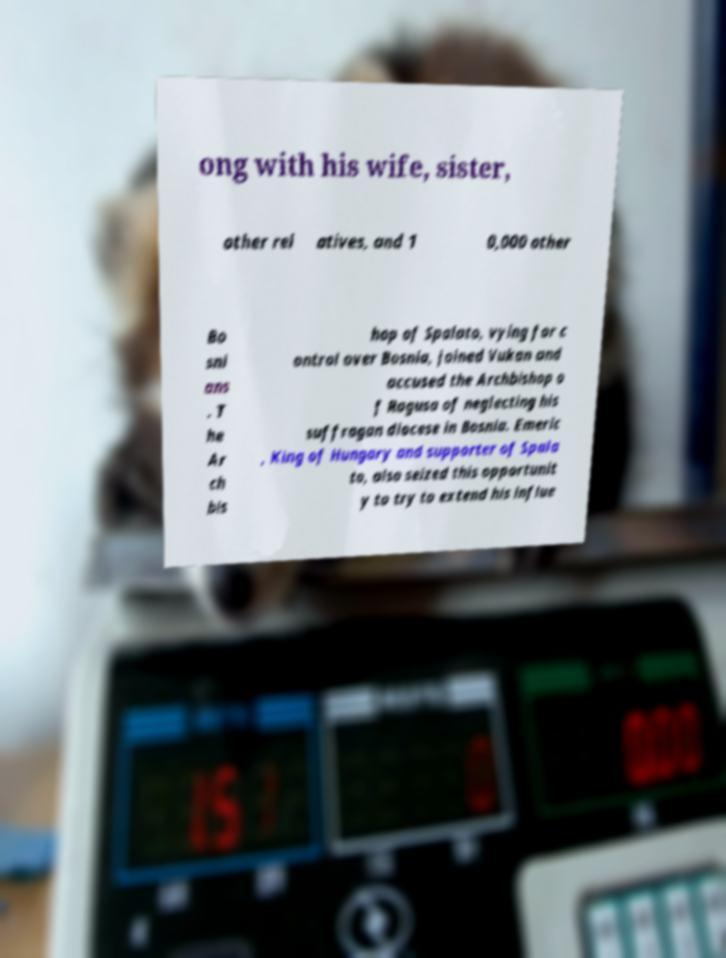For documentation purposes, I need the text within this image transcribed. Could you provide that? ong with his wife, sister, other rel atives, and 1 0,000 other Bo sni ans . T he Ar ch bis hop of Spalato, vying for c ontrol over Bosnia, joined Vukan and accused the Archbishop o f Ragusa of neglecting his suffragan diocese in Bosnia. Emeric , King of Hungary and supporter of Spala to, also seized this opportunit y to try to extend his influe 